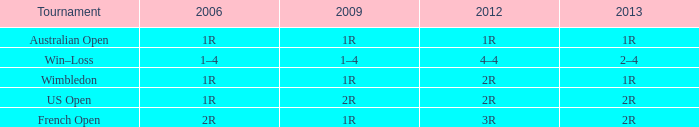What is the 2006 when the 2013 is 2r, and a Tournament was the us open? 1R. 